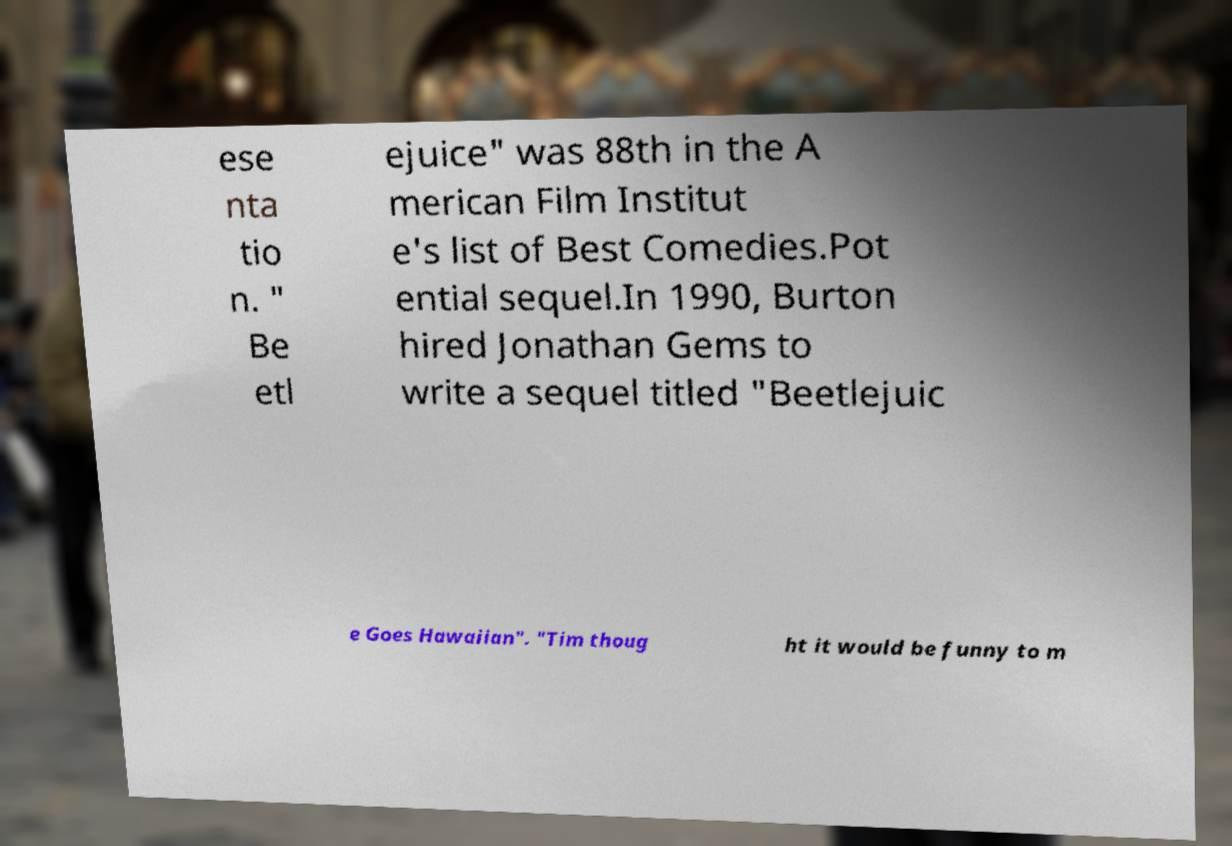What messages or text are displayed in this image? I need them in a readable, typed format. ese nta tio n. " Be etl ejuice" was 88th in the A merican Film Institut e's list of Best Comedies.Pot ential sequel.In 1990, Burton hired Jonathan Gems to write a sequel titled "Beetlejuic e Goes Hawaiian". "Tim thoug ht it would be funny to m 